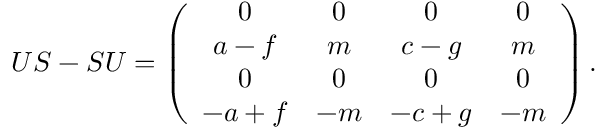Convert formula to latex. <formula><loc_0><loc_0><loc_500><loc_500>U S - S U = \left ( \begin{array} { c c c c } { 0 } & { 0 } & { 0 } & { 0 } \\ { a - f } & { m } & { c - g } & { m } \\ { 0 } & { 0 } & { 0 } & { 0 } \\ { - a + f } & { - m } & { - c + g } & { - m } \end{array} \right ) .</formula> 